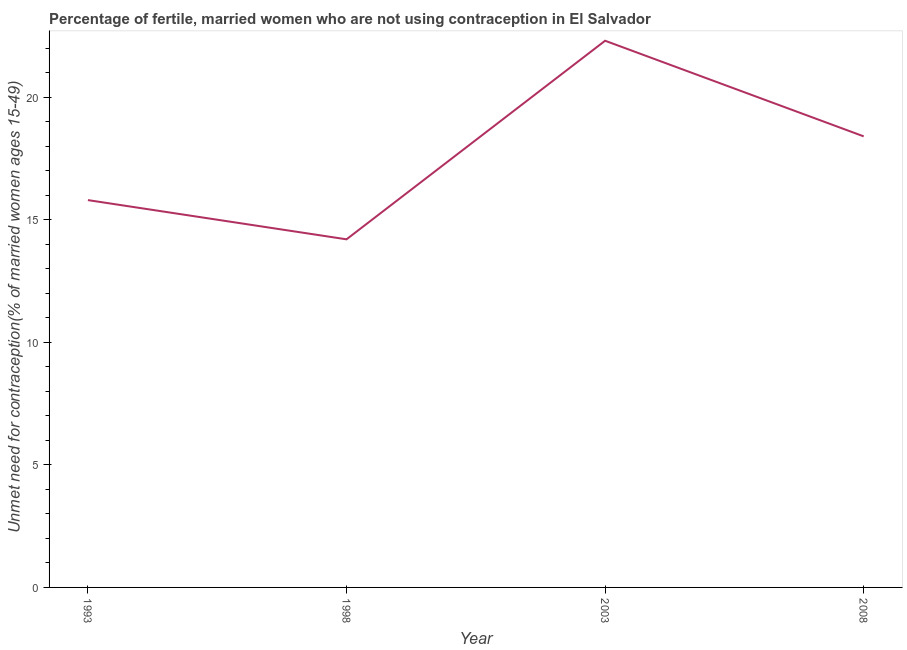Across all years, what is the maximum number of married women who are not using contraception?
Provide a short and direct response. 22.3. Across all years, what is the minimum number of married women who are not using contraception?
Offer a very short reply. 14.2. In which year was the number of married women who are not using contraception minimum?
Your response must be concise. 1998. What is the sum of the number of married women who are not using contraception?
Give a very brief answer. 70.7. What is the difference between the number of married women who are not using contraception in 1998 and 2008?
Give a very brief answer. -4.2. What is the average number of married women who are not using contraception per year?
Keep it short and to the point. 17.67. What is the median number of married women who are not using contraception?
Your answer should be compact. 17.1. In how many years, is the number of married women who are not using contraception greater than 4 %?
Keep it short and to the point. 4. Do a majority of the years between 1993 and 2008 (inclusive) have number of married women who are not using contraception greater than 21 %?
Your answer should be very brief. No. What is the ratio of the number of married women who are not using contraception in 2003 to that in 2008?
Offer a terse response. 1.21. Is the number of married women who are not using contraception in 2003 less than that in 2008?
Provide a short and direct response. No. What is the difference between the highest and the second highest number of married women who are not using contraception?
Offer a terse response. 3.9. Is the sum of the number of married women who are not using contraception in 1998 and 2008 greater than the maximum number of married women who are not using contraception across all years?
Ensure brevity in your answer.  Yes. What is the difference between the highest and the lowest number of married women who are not using contraception?
Your answer should be compact. 8.1. How many lines are there?
Your answer should be compact. 1. What is the difference between two consecutive major ticks on the Y-axis?
Offer a terse response. 5. Are the values on the major ticks of Y-axis written in scientific E-notation?
Make the answer very short. No. Does the graph contain any zero values?
Keep it short and to the point. No. What is the title of the graph?
Your response must be concise. Percentage of fertile, married women who are not using contraception in El Salvador. What is the label or title of the Y-axis?
Provide a succinct answer.  Unmet need for contraception(% of married women ages 15-49). What is the  Unmet need for contraception(% of married women ages 15-49) of 1998?
Provide a succinct answer. 14.2. What is the  Unmet need for contraception(% of married women ages 15-49) of 2003?
Provide a succinct answer. 22.3. What is the  Unmet need for contraception(% of married women ages 15-49) in 2008?
Give a very brief answer. 18.4. What is the difference between the  Unmet need for contraception(% of married women ages 15-49) in 1993 and 2003?
Offer a very short reply. -6.5. What is the difference between the  Unmet need for contraception(% of married women ages 15-49) in 1993 and 2008?
Give a very brief answer. -2.6. What is the difference between the  Unmet need for contraception(% of married women ages 15-49) in 1998 and 2008?
Keep it short and to the point. -4.2. What is the difference between the  Unmet need for contraception(% of married women ages 15-49) in 2003 and 2008?
Your answer should be compact. 3.9. What is the ratio of the  Unmet need for contraception(% of married women ages 15-49) in 1993 to that in 1998?
Your response must be concise. 1.11. What is the ratio of the  Unmet need for contraception(% of married women ages 15-49) in 1993 to that in 2003?
Give a very brief answer. 0.71. What is the ratio of the  Unmet need for contraception(% of married women ages 15-49) in 1993 to that in 2008?
Give a very brief answer. 0.86. What is the ratio of the  Unmet need for contraception(% of married women ages 15-49) in 1998 to that in 2003?
Provide a short and direct response. 0.64. What is the ratio of the  Unmet need for contraception(% of married women ages 15-49) in 1998 to that in 2008?
Keep it short and to the point. 0.77. What is the ratio of the  Unmet need for contraception(% of married women ages 15-49) in 2003 to that in 2008?
Make the answer very short. 1.21. 